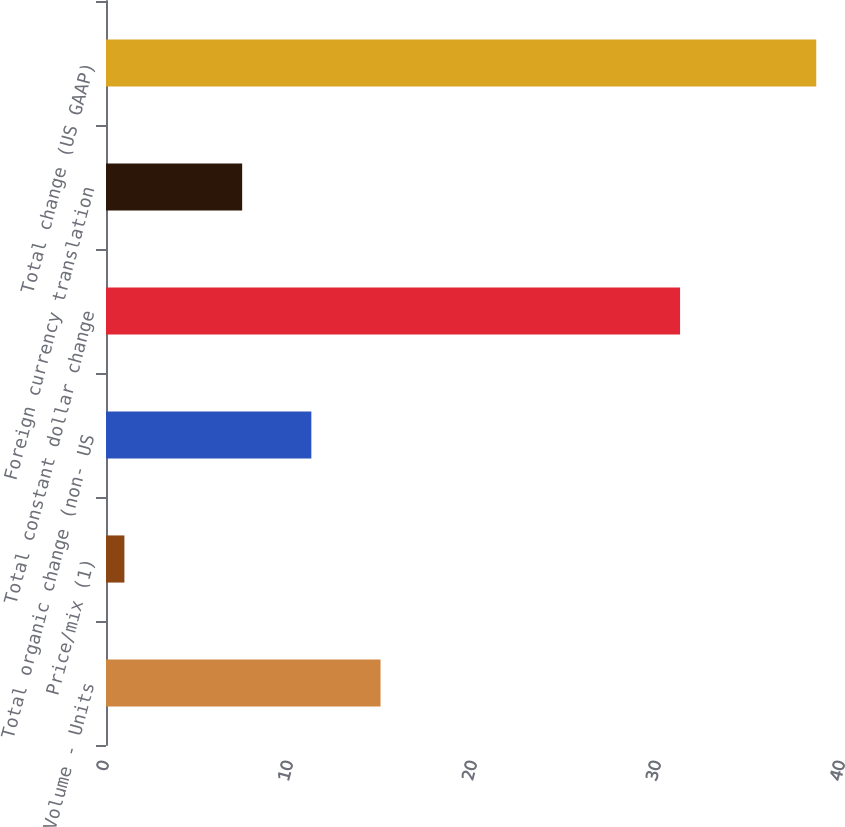Convert chart to OTSL. <chart><loc_0><loc_0><loc_500><loc_500><bar_chart><fcel>Volume - Units<fcel>Price/mix (1)<fcel>Total organic change (non- US<fcel>Total constant dollar change<fcel>Foreign currency translation<fcel>Total change (US GAAP)<nl><fcel>14.92<fcel>1<fcel>11.16<fcel>31.2<fcel>7.4<fcel>38.6<nl></chart> 